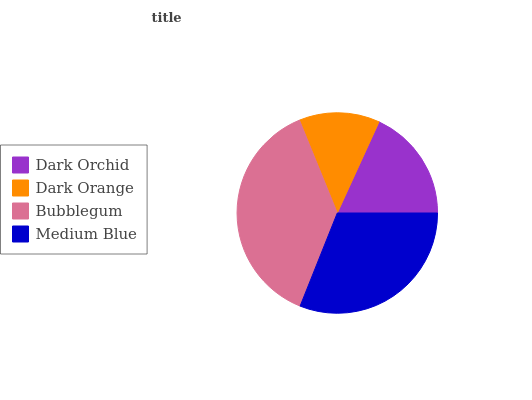Is Dark Orange the minimum?
Answer yes or no. Yes. Is Bubblegum the maximum?
Answer yes or no. Yes. Is Bubblegum the minimum?
Answer yes or no. No. Is Dark Orange the maximum?
Answer yes or no. No. Is Bubblegum greater than Dark Orange?
Answer yes or no. Yes. Is Dark Orange less than Bubblegum?
Answer yes or no. Yes. Is Dark Orange greater than Bubblegum?
Answer yes or no. No. Is Bubblegum less than Dark Orange?
Answer yes or no. No. Is Medium Blue the high median?
Answer yes or no. Yes. Is Dark Orchid the low median?
Answer yes or no. Yes. Is Bubblegum the high median?
Answer yes or no. No. Is Bubblegum the low median?
Answer yes or no. No. 